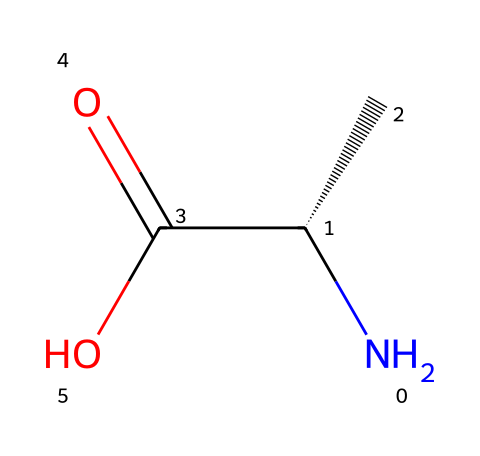how many carbon atoms are in this compound? The SMILES representation shows one 'C' in the N[C@@H](C) section and another 'C' in the C(=O)O part, totaling two carbon atoms.
Answer: two what functional groups are present in this compound? The SMILES contains a carboxyl group (C(=O)O) and an amine group (N), indicating both functional groups are present in the compound.
Answer: carboxyl and amine is this compound chiral? The presence of a stereocenter at the carbon attached to the amine (C@@H) indicates that this compound is chiral.
Answer: yes what is the primary amine in this compound? The amine group (N) attached to the chiral carbon constitutes the primary amine, defining its primary nature.
Answer: primary amine how many chiral centers does this compound have? The visualization of the structure shows one chiral carbon that is associated with the 'C@@H' notation, indicating only one chiral center.
Answer: one what type of amino acid does this compound represent? This compound represents an aliphatic amino acid due to its structural characteristics lacking aromatic or sulfur-containing groups.
Answer: aliphatic 